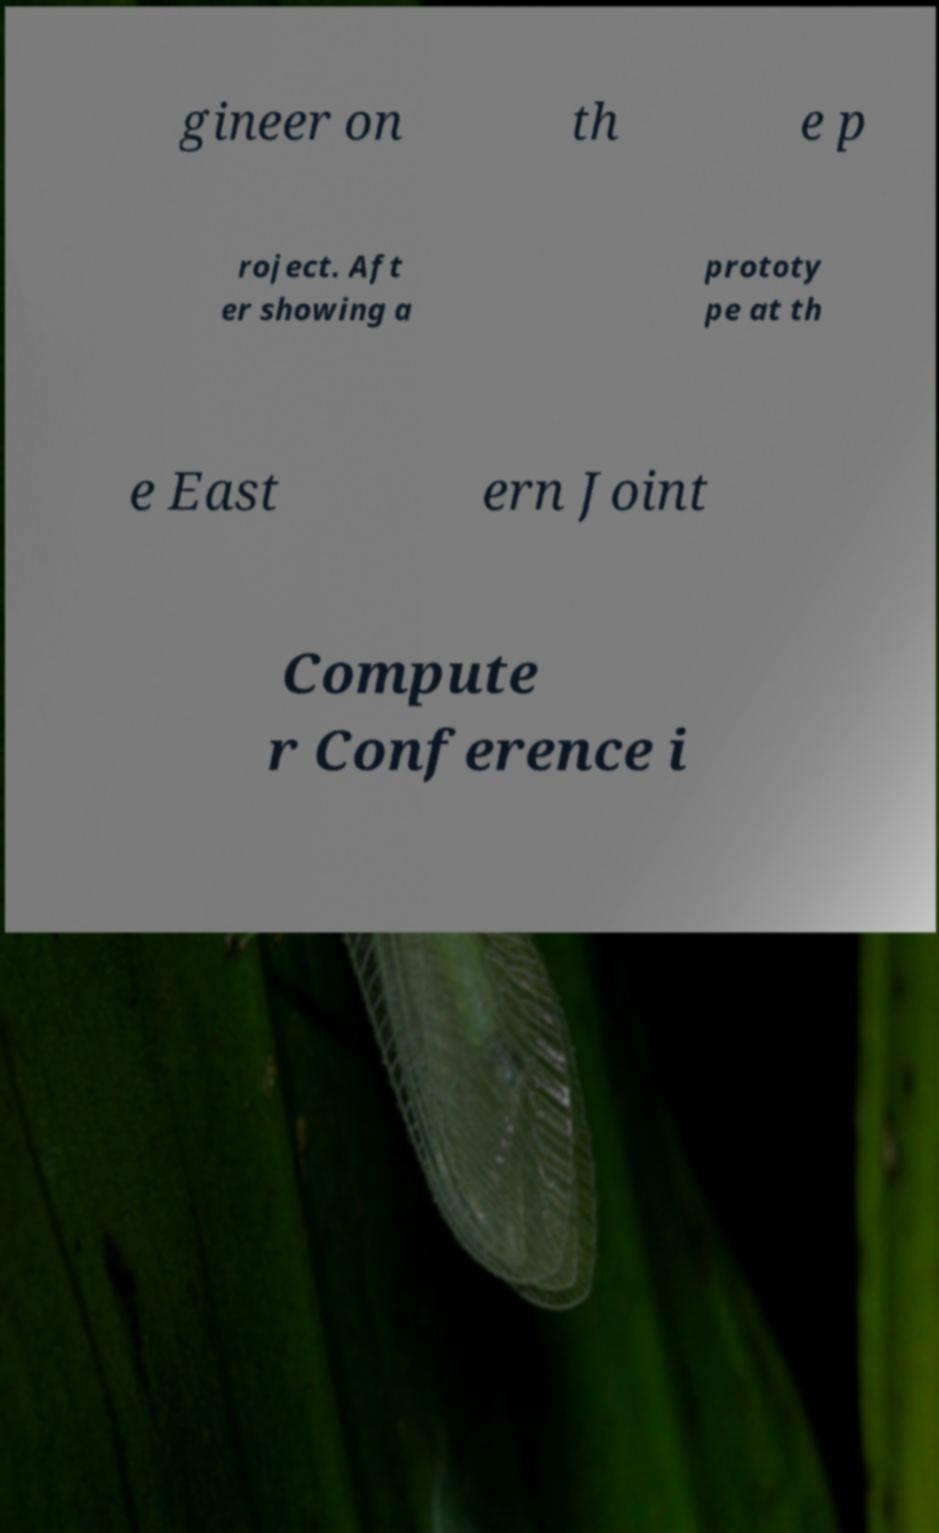Please identify and transcribe the text found in this image. gineer on th e p roject. Aft er showing a prototy pe at th e East ern Joint Compute r Conference i 